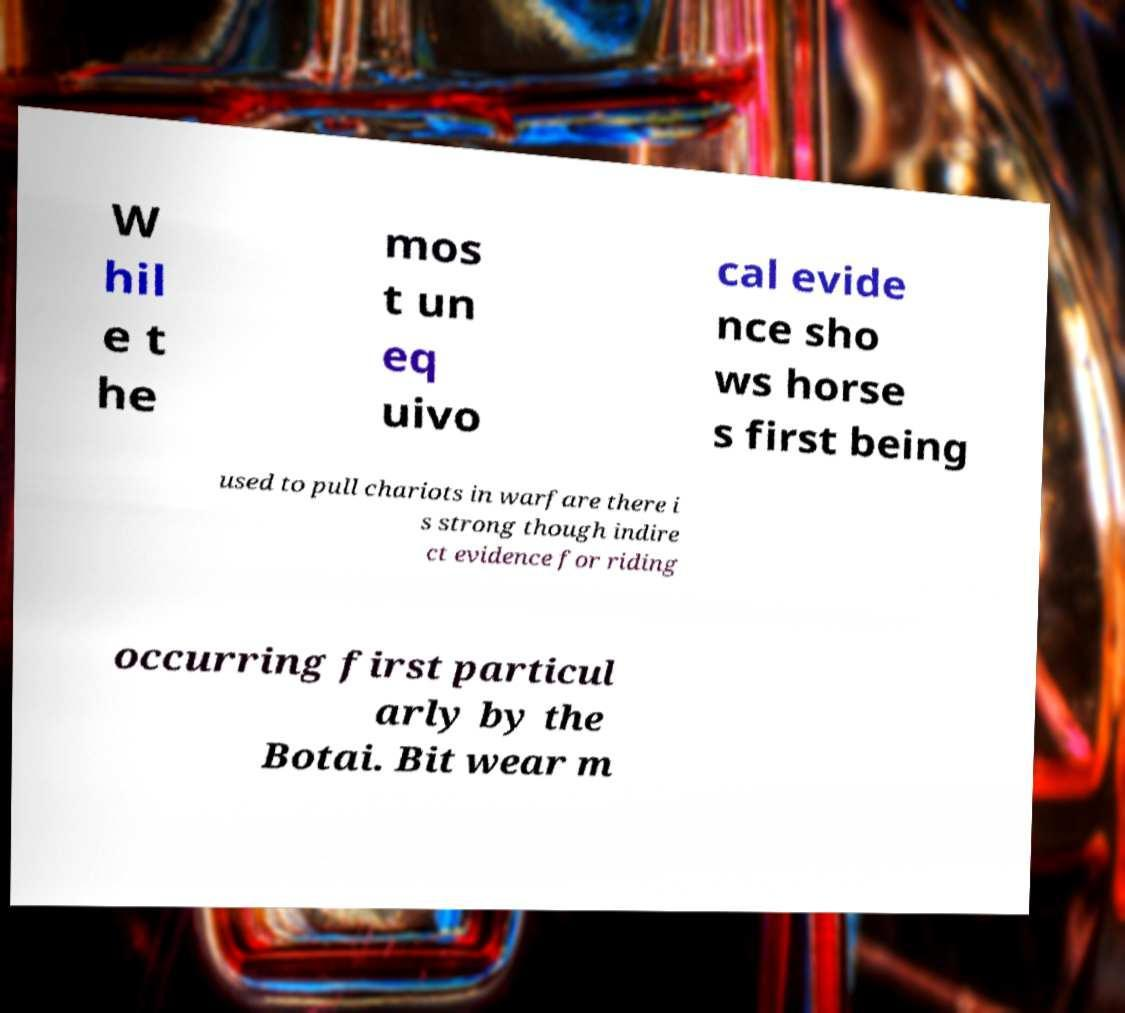Could you assist in decoding the text presented in this image and type it out clearly? W hil e t he mos t un eq uivo cal evide nce sho ws horse s first being used to pull chariots in warfare there i s strong though indire ct evidence for riding occurring first particul arly by the Botai. Bit wear m 